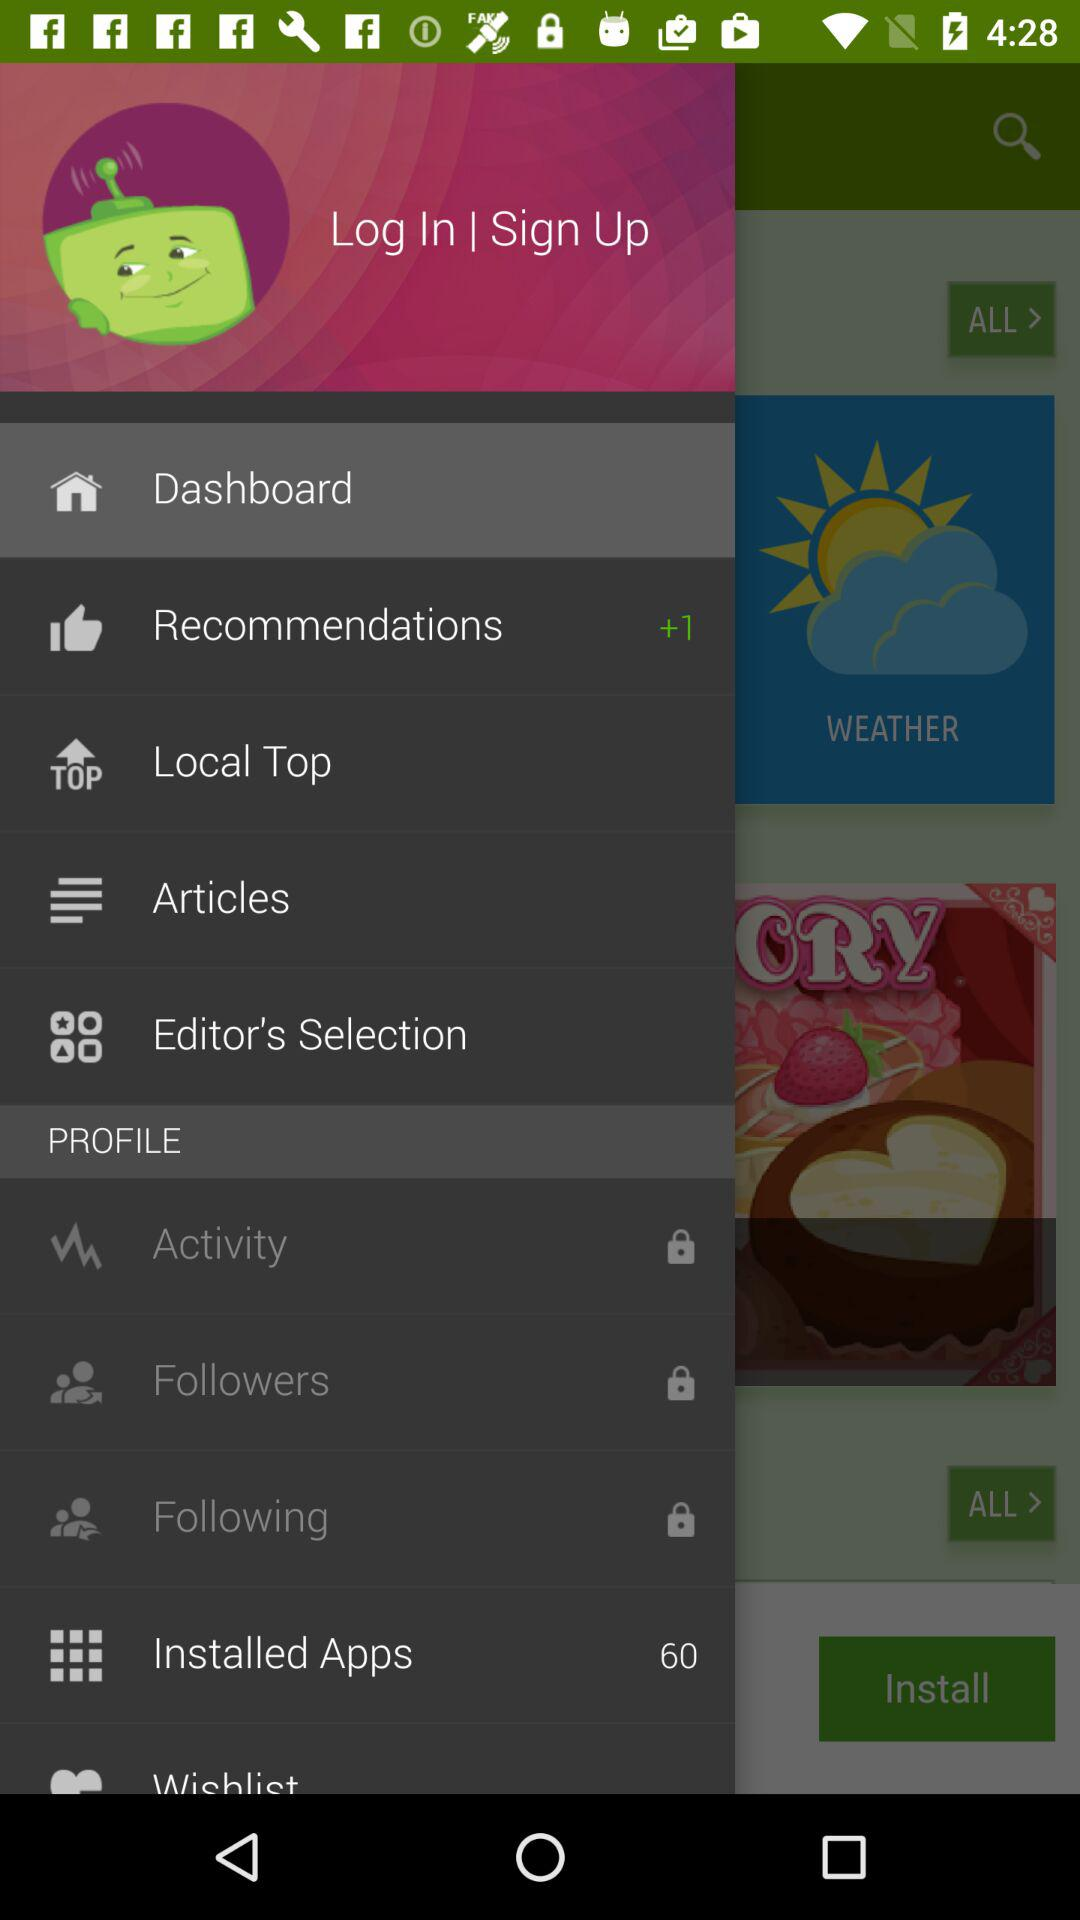How many installed applications are there? There are 60 installed applications. 